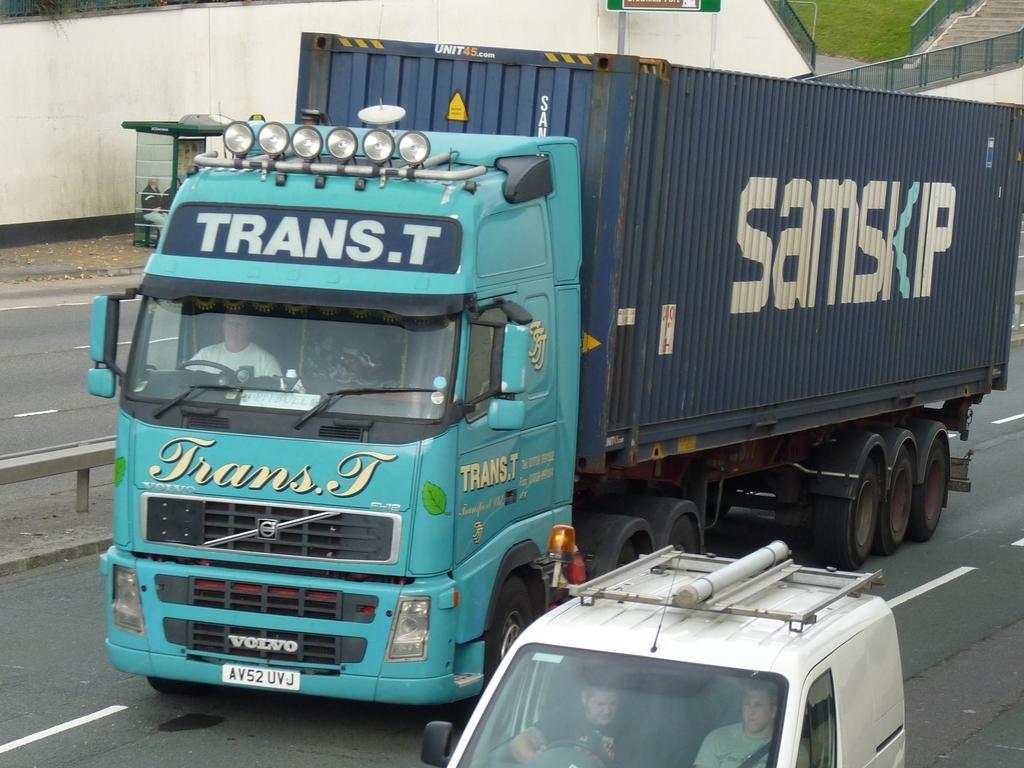Describe this image in one or two sentences. On the road there is a big truck driven by man and beside that there is a man driving a car and opposite to that road there is a man sitting on the booth. 